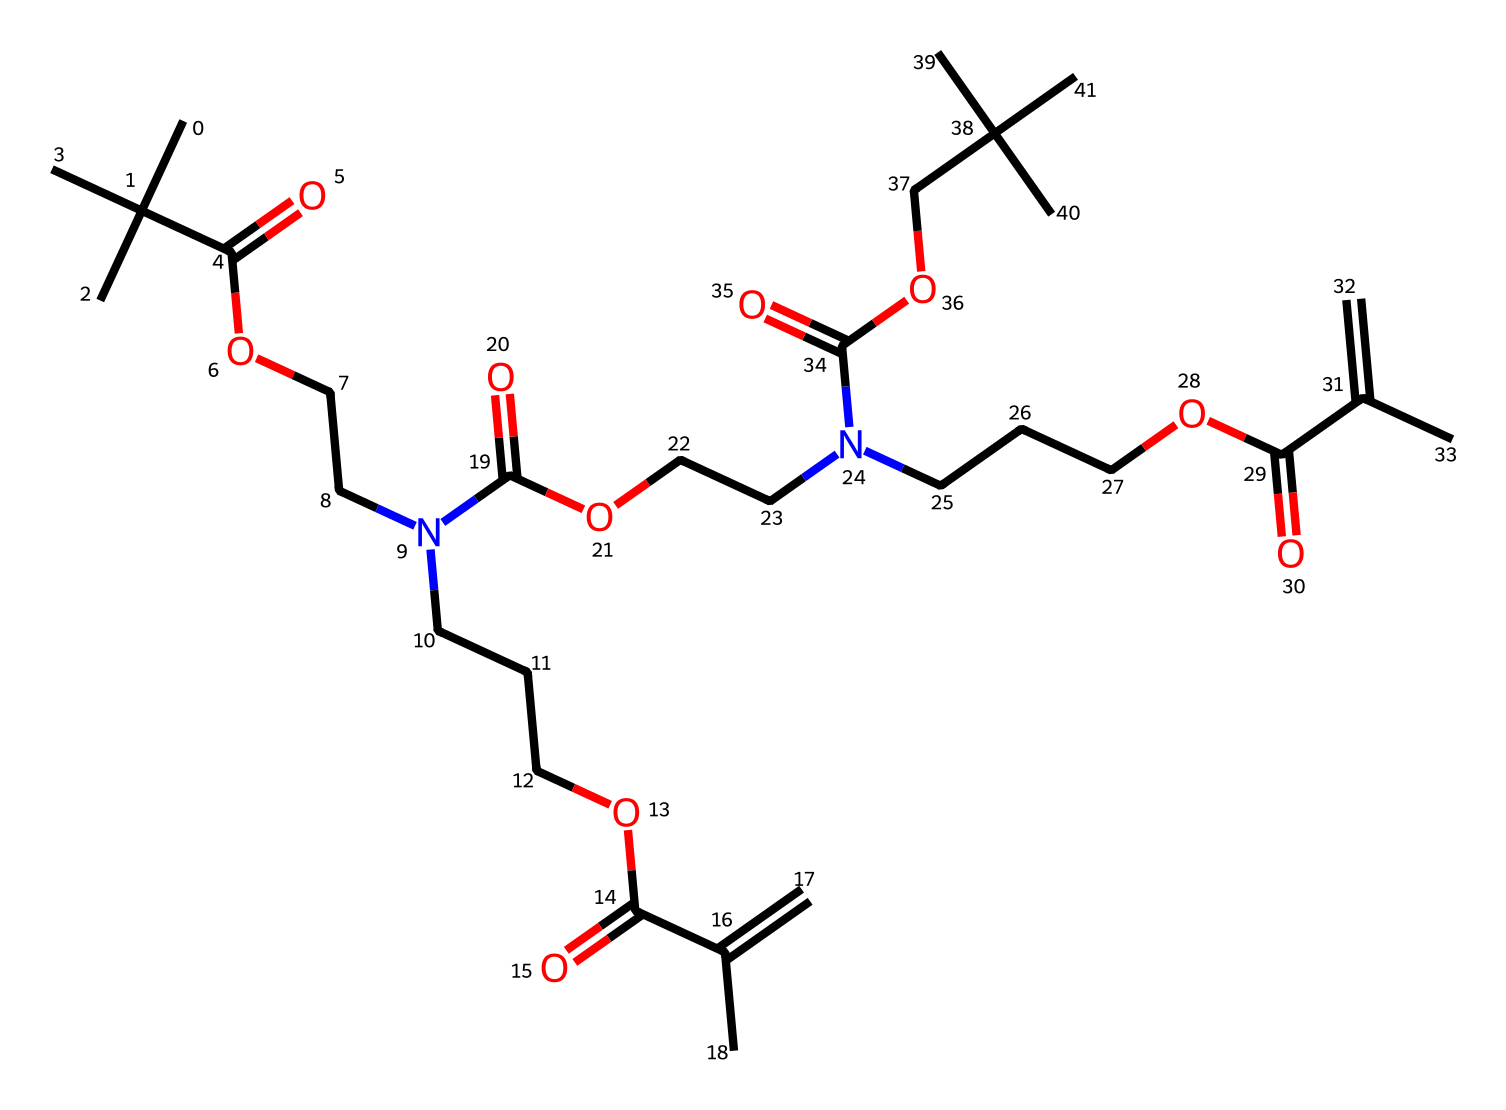What is the molecular weight of this compound? To calculate the molecular weight, I would identify each atom in the SMILES representation and sum their respective atomic weights based on the number of occurrences: carbon (C), hydrogen (H), nitrogen (N), and oxygen (O). After counting, the molecular weight is approximately 878 g/mol.
Answer: 878 g/mol How many carbon atoms are present in this structure? I can count each carbon atom (C) from the SMILES. There are numerous instances of carbon, specifically: at least 14 carbons in the straight chains and branches. Therefore, there are 27 carbon atoms in total in the chemical structure.
Answer: 27 What type of functional groups can be identified in this photoresist? By analyzing the SMILES representation, I notice multiple ester (RCOOR') and carboxylic acid (RCOOH) functional groups. These are distinctive in the structure, suggesting its functional characteristics.
Answer: ester and carboxylic acid Does this compound have amine groups? Observing the SMILES representation, I can identify “N” which indicates nitrogen atoms. These are connected to carbons, suggesting the presence of amine functional groups in the chemical structure.
Answer: yes Is this photoresist likely to have good UV curability based on its structure? Evaluating the presence of unsaturated carbon-carbon double bonds (C=C) indicates the potential for UV curability in this resin, as these unsaturated bonds are essential for cross-linking during curing when exposed to UV light.
Answer: yes 